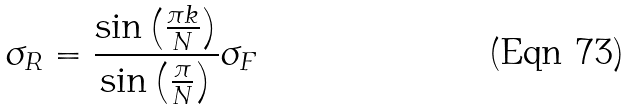<formula> <loc_0><loc_0><loc_500><loc_500>\sigma _ { R } = \frac { \sin \left ( \frac { \pi k } { N } \right ) } { \sin \left ( \frac { \pi } { N } \right ) } \sigma _ { F }</formula> 